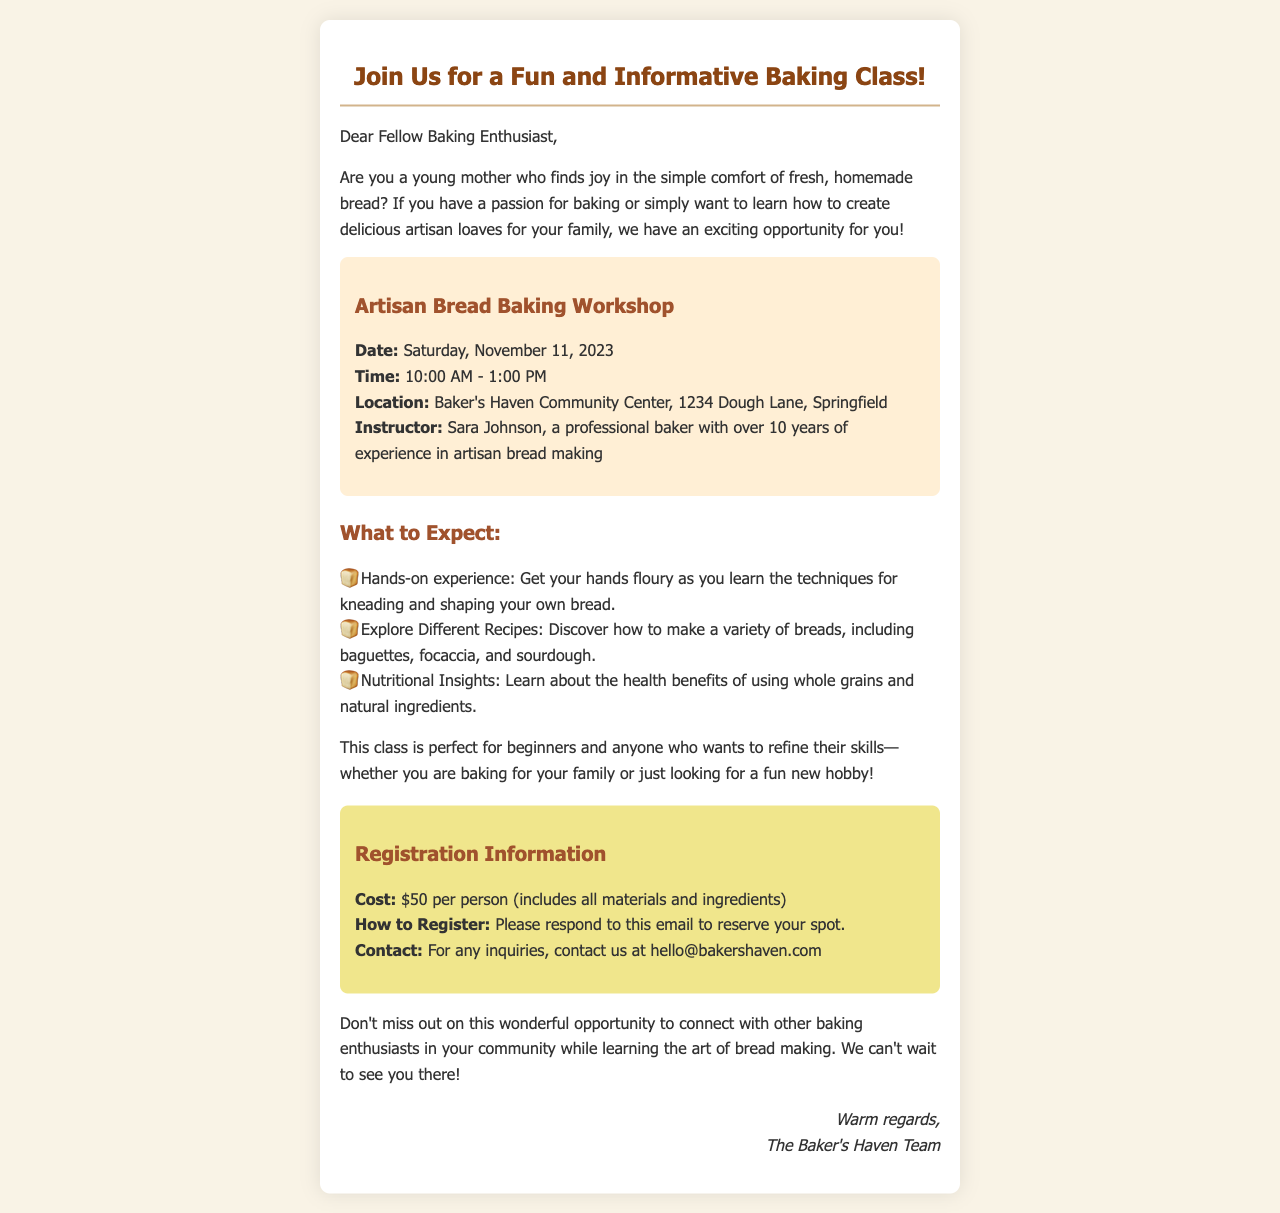What is the date of the baking class? The date of the baking class is specified in the document as Saturday, November 11, 2023.
Answer: Saturday, November 11, 2023 Who is the instructor for the workshop? The document mentions the instructor's name, Sara Johnson, and her background as a professional baker.
Answer: Sara Johnson What is the cost to register for the class? The document clearly states that the cost of the class is $50 per person.
Answer: $50 What will participants learn in the class? The document outlines several learning goals including techniques for kneading and shaping bread.
Answer: Techniques for kneading and shaping bread Where is the baking class being held? The location of the class is provided, specifically at Baker's Haven Community Center on Dough Lane.
Answer: Baker's Haven Community Center, 1234 Dough Lane, Springfield Why is this class suitable for beginners? The document mentions that the class is perfect for beginners or anyone looking to refine their skills.
Answer: Perfect for beginners How long does the baking class last? The duration of the class is specified as three hours, from 10:00 AM to 1:00 PM.
Answer: Three hours What should you do to reserve your spot? The document advises that you can reserve your spot by responding to the email.
Answer: Respond to this email 